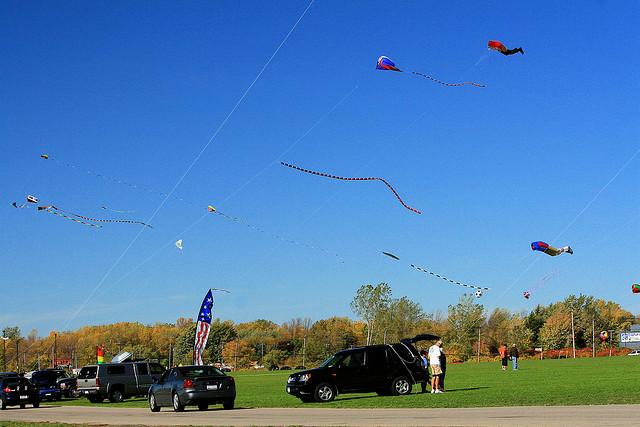Which kite is furthest away?
Give a very brief answer. One that can't be seen. Are any of the vehicles in motion?
Give a very brief answer. No. What is in the sky?
Give a very brief answer. Kites. What event has taken place here?
Keep it brief. Kite flying. What color are the cars?
Give a very brief answer. Black. Do you see a picnic table?
Quick response, please. No. 